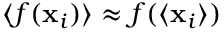<formula> <loc_0><loc_0><loc_500><loc_500>\langle f ( x _ { i } ) \rangle \approx f ( \langle x _ { i } \rangle )</formula> 